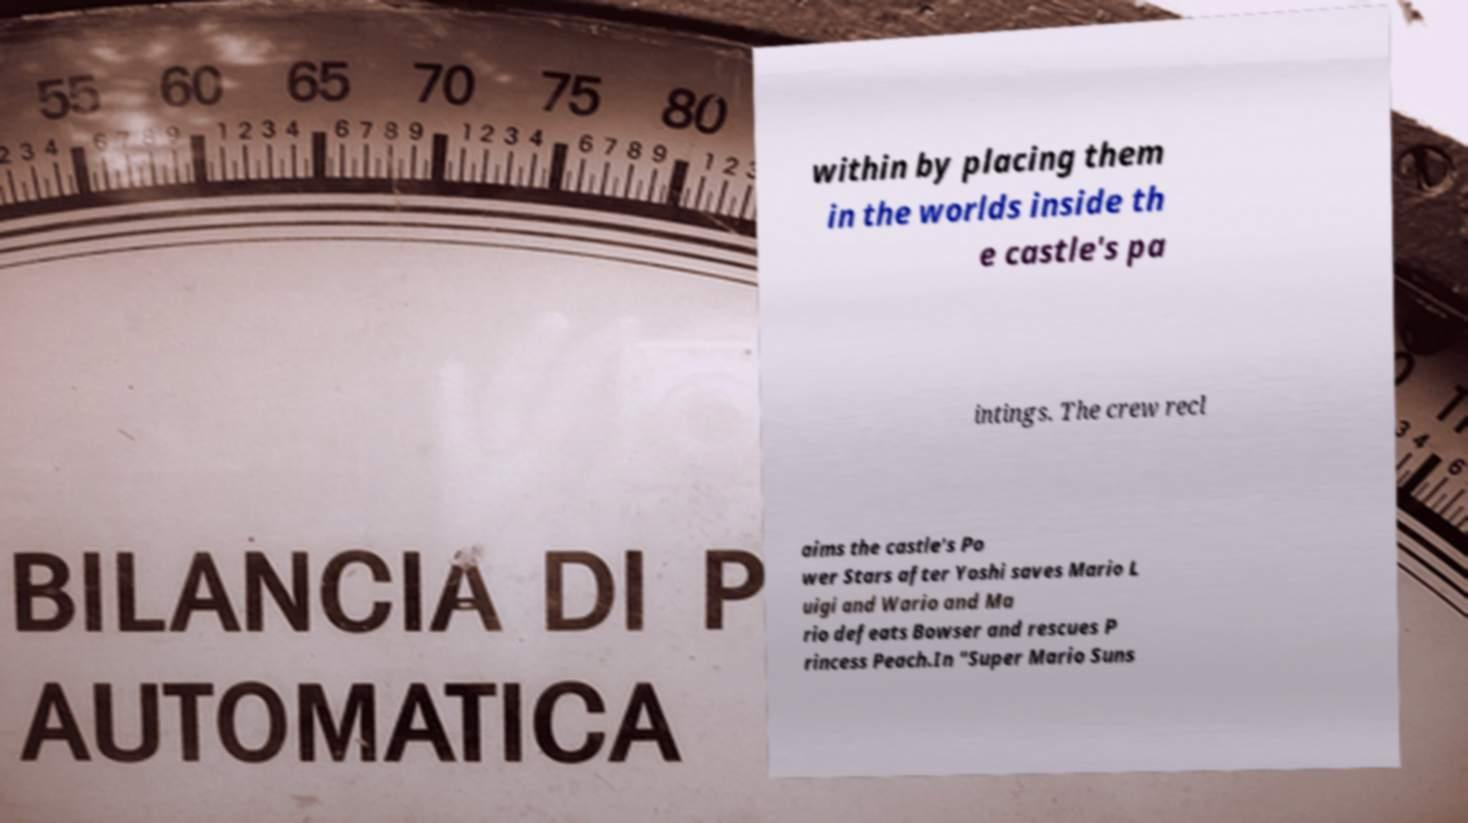I need the written content from this picture converted into text. Can you do that? within by placing them in the worlds inside th e castle's pa intings. The crew recl aims the castle's Po wer Stars after Yoshi saves Mario L uigi and Wario and Ma rio defeats Bowser and rescues P rincess Peach.In "Super Mario Suns 